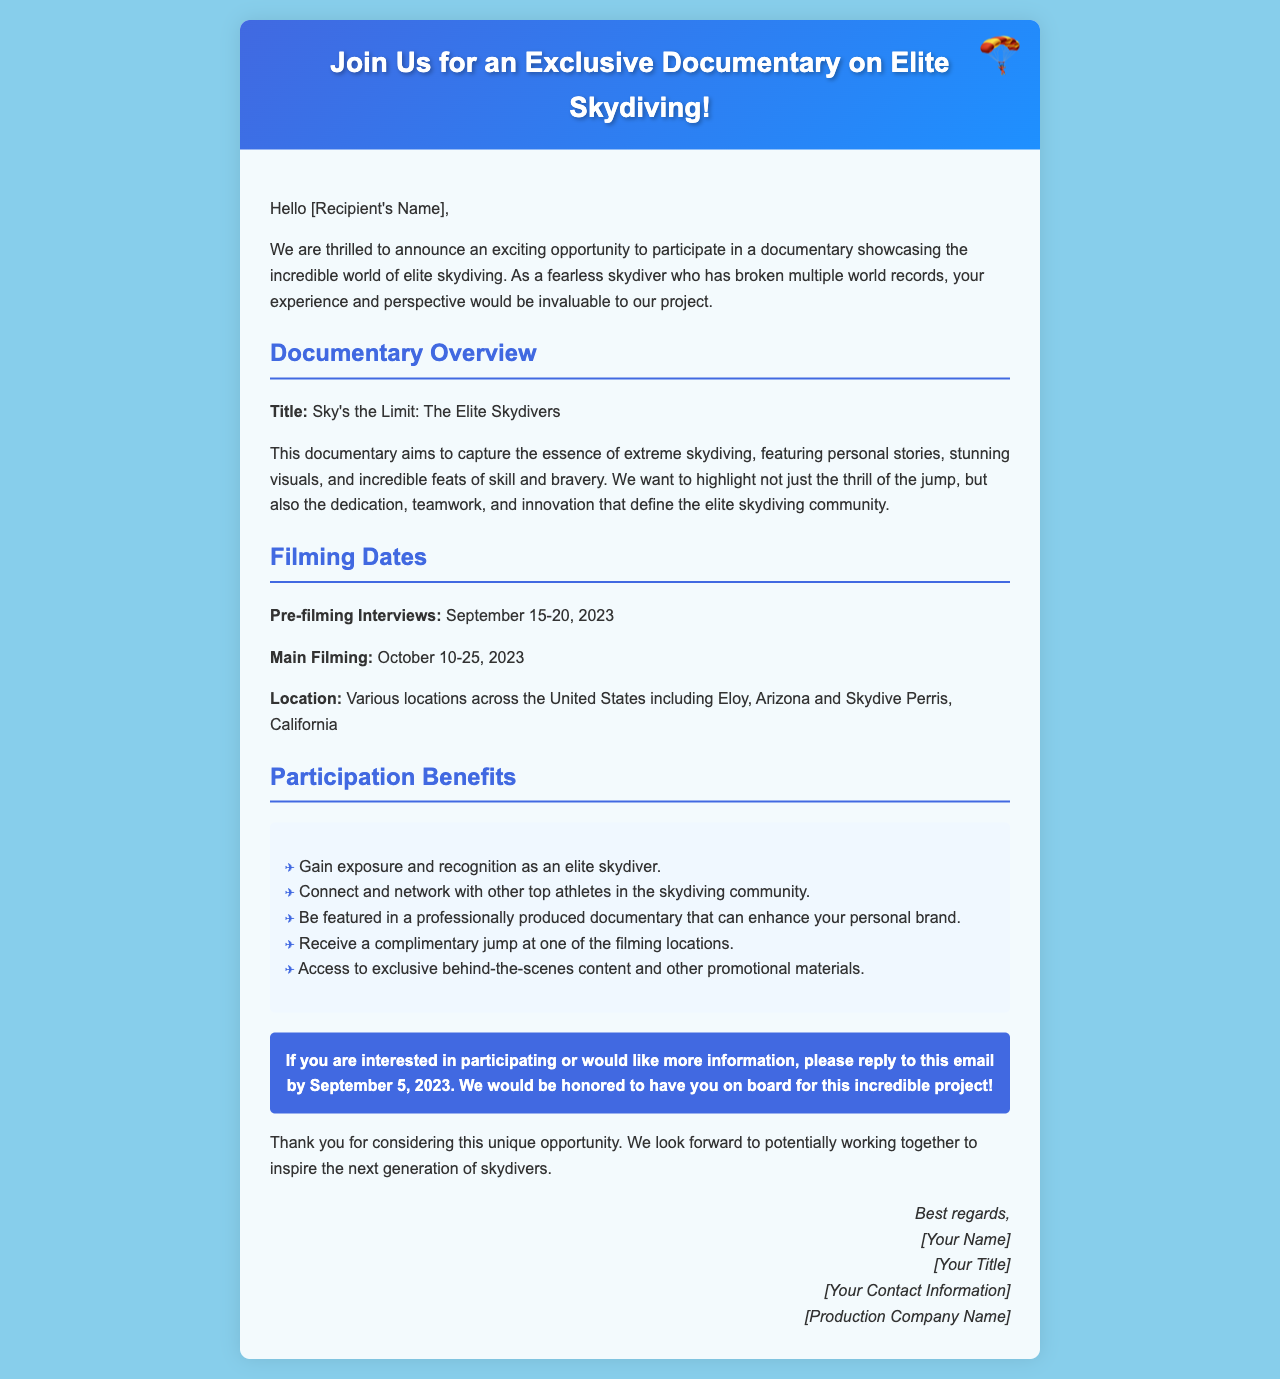What is the title of the documentary? The title of the documentary is provided in the overview section of the document.
Answer: Sky's the Limit: The Elite Skydivers What are the main filming dates? The main filming dates are listed in the filming dates section of the document.
Answer: October 10-25, 2023 Where will the filming locations be? The document specifies various locations for filming in the United States.
Answer: Eloy, Arizona and Skydive Perris, California What is the deadline to reply if interested? The deadline for interest is noted in the call to action section of the document.
Answer: September 5, 2023 Which benefit includes a jump? One of the benefits mentions a specific action related to skydiving participation.
Answer: Receive a complimentary jump at one of the filming locations Why might participating in the documentary be beneficial for an elite skydiver? The document explains several benefits that can enhance a skydiver's personal brand and networking opportunities.
Answer: Gain exposure and recognition as an elite skydiver 